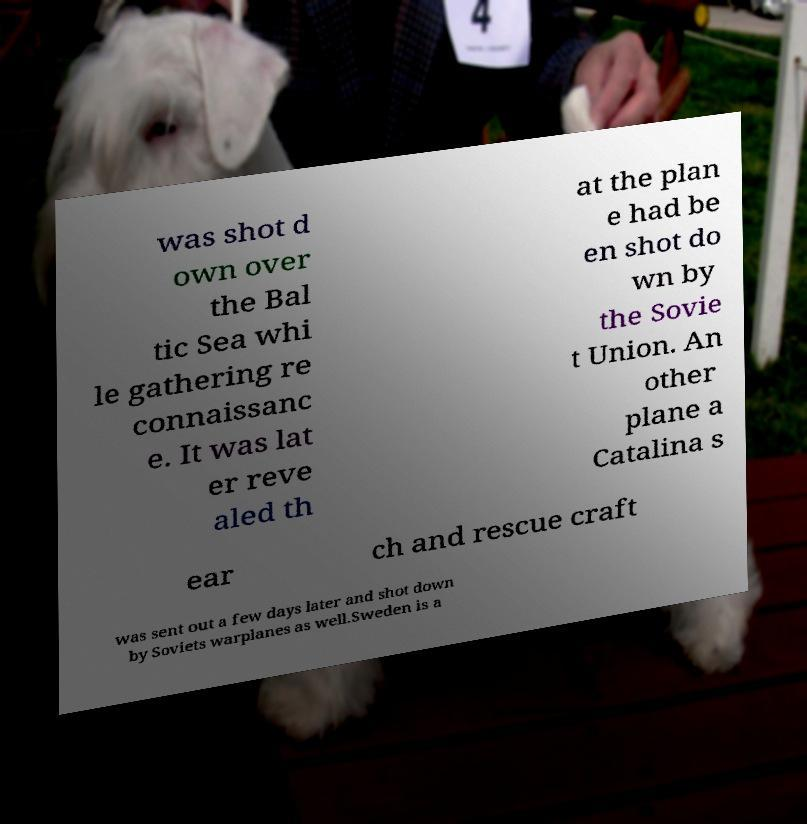I need the written content from this picture converted into text. Can you do that? was shot d own over the Bal tic Sea whi le gathering re connaissanc e. It was lat er reve aled th at the plan e had be en shot do wn by the Sovie t Union. An other plane a Catalina s ear ch and rescue craft was sent out a few days later and shot down by Soviets warplanes as well.Sweden is a 